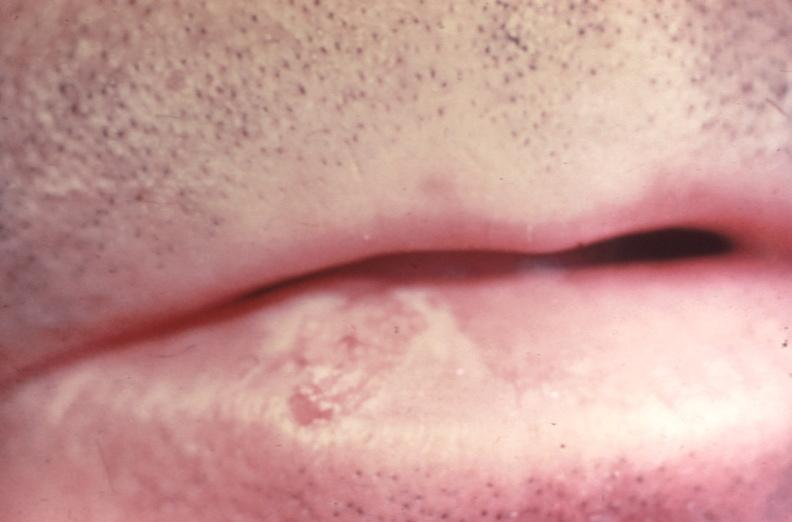does this image show squamous cell carcinoma, lip?
Answer the question using a single word or phrase. Yes 